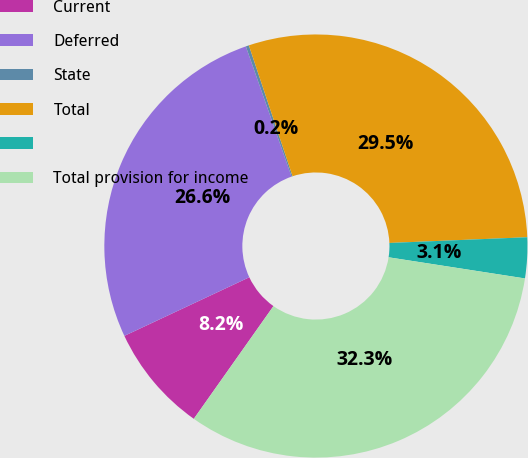<chart> <loc_0><loc_0><loc_500><loc_500><pie_chart><fcel>Current<fcel>Deferred<fcel>State<fcel>Total<fcel>Unnamed: 4<fcel>Total provision for income<nl><fcel>8.23%<fcel>26.61%<fcel>0.24%<fcel>29.47%<fcel>3.11%<fcel>32.34%<nl></chart> 